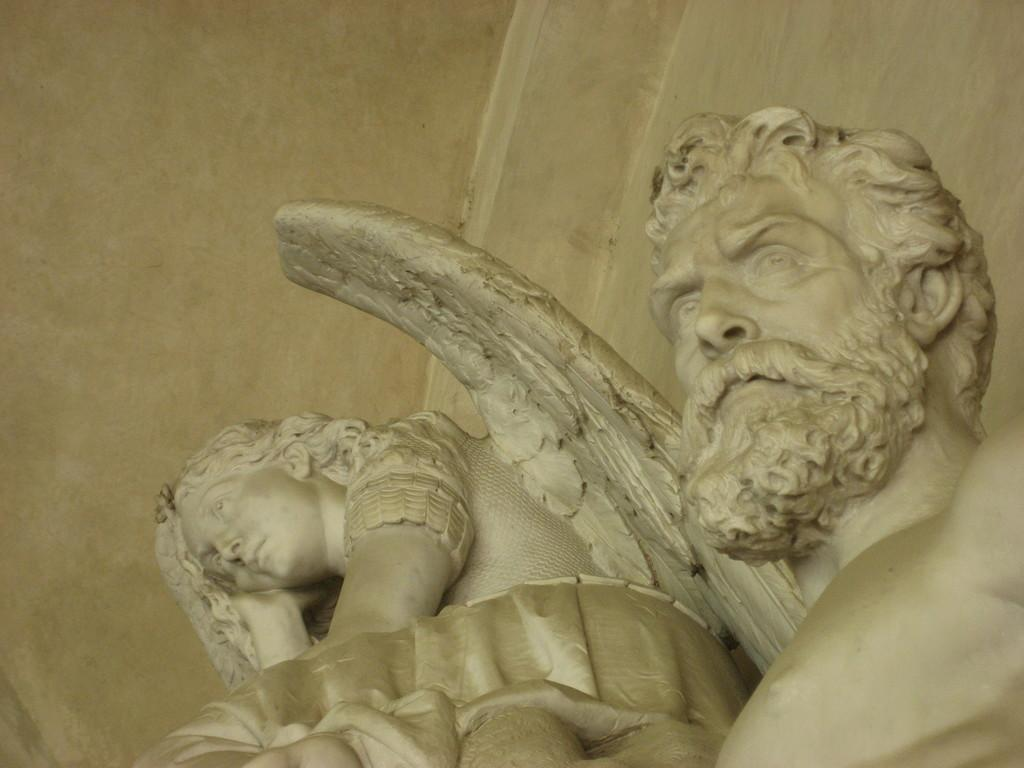What type of objects can be seen in the image? There are statues in the image. What else is present in the image besides the statues? There is a wall in the image. What is the purpose of the group of people in the image? There are no people present in the image, only statues. The purpose of the statues cannot be determined from the image. 